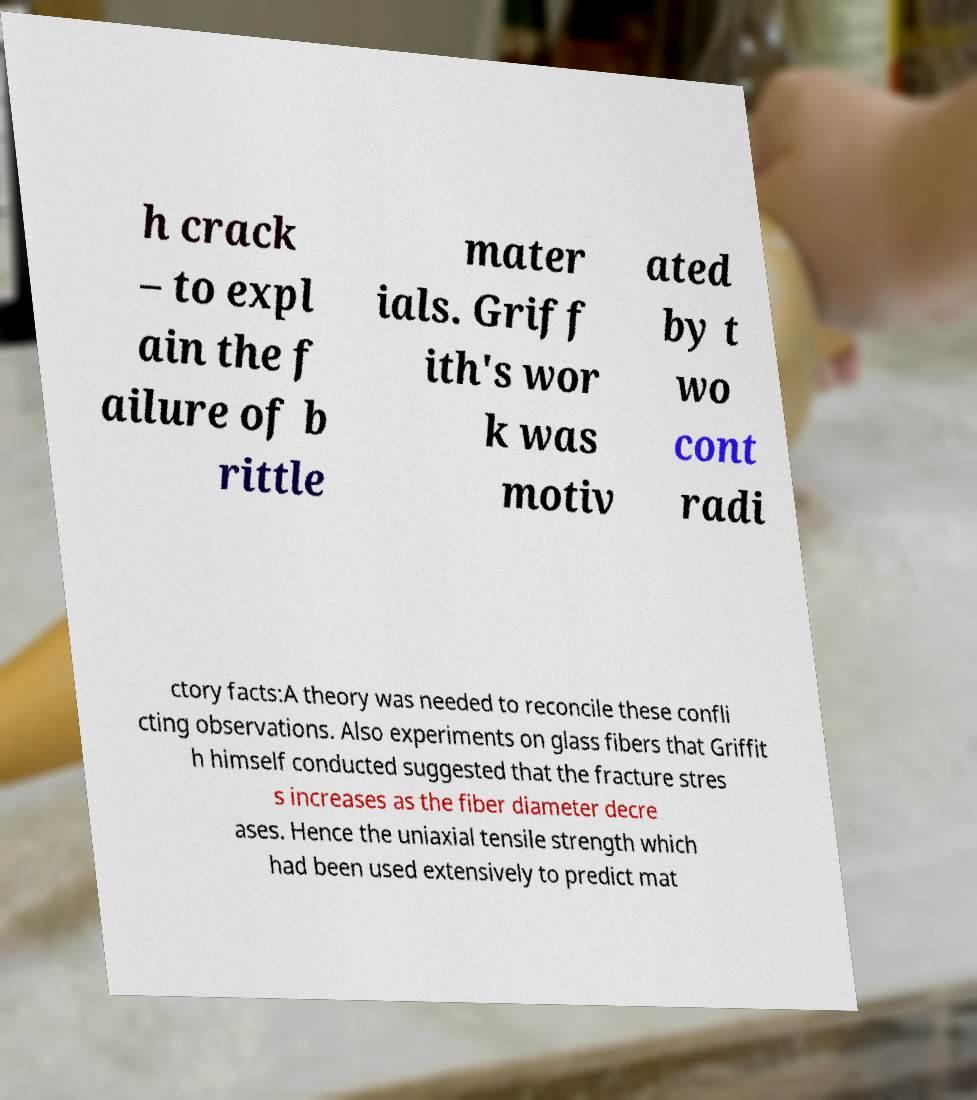I need the written content from this picture converted into text. Can you do that? h crack – to expl ain the f ailure of b rittle mater ials. Griff ith's wor k was motiv ated by t wo cont radi ctory facts:A theory was needed to reconcile these confli cting observations. Also experiments on glass fibers that Griffit h himself conducted suggested that the fracture stres s increases as the fiber diameter decre ases. Hence the uniaxial tensile strength which had been used extensively to predict mat 